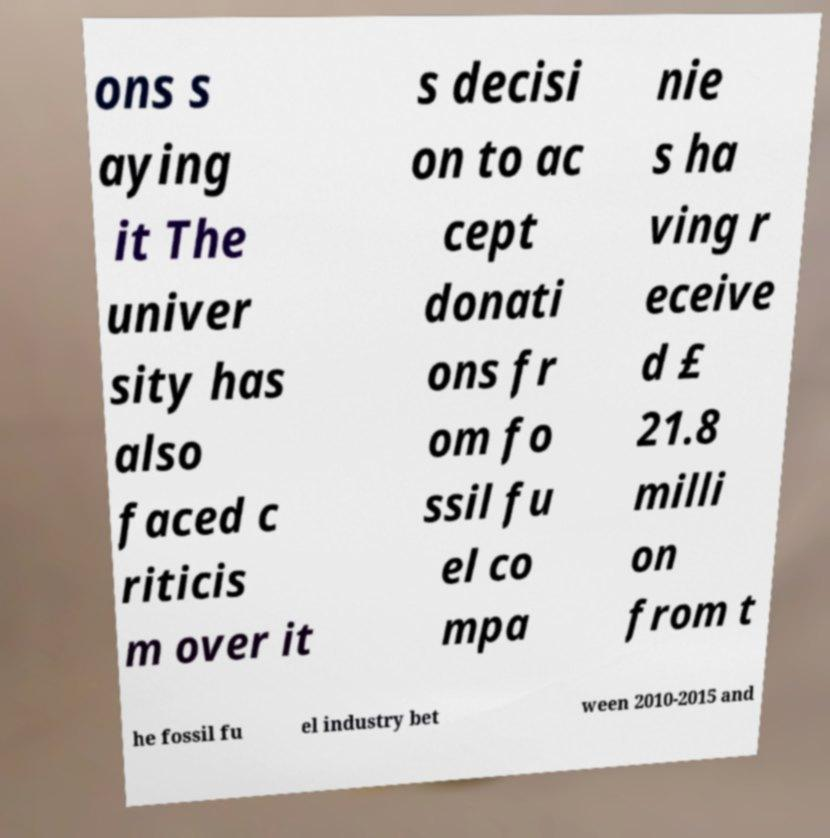Could you extract and type out the text from this image? ons s aying it The univer sity has also faced c riticis m over it s decisi on to ac cept donati ons fr om fo ssil fu el co mpa nie s ha ving r eceive d £ 21.8 milli on from t he fossil fu el industry bet ween 2010-2015 and 